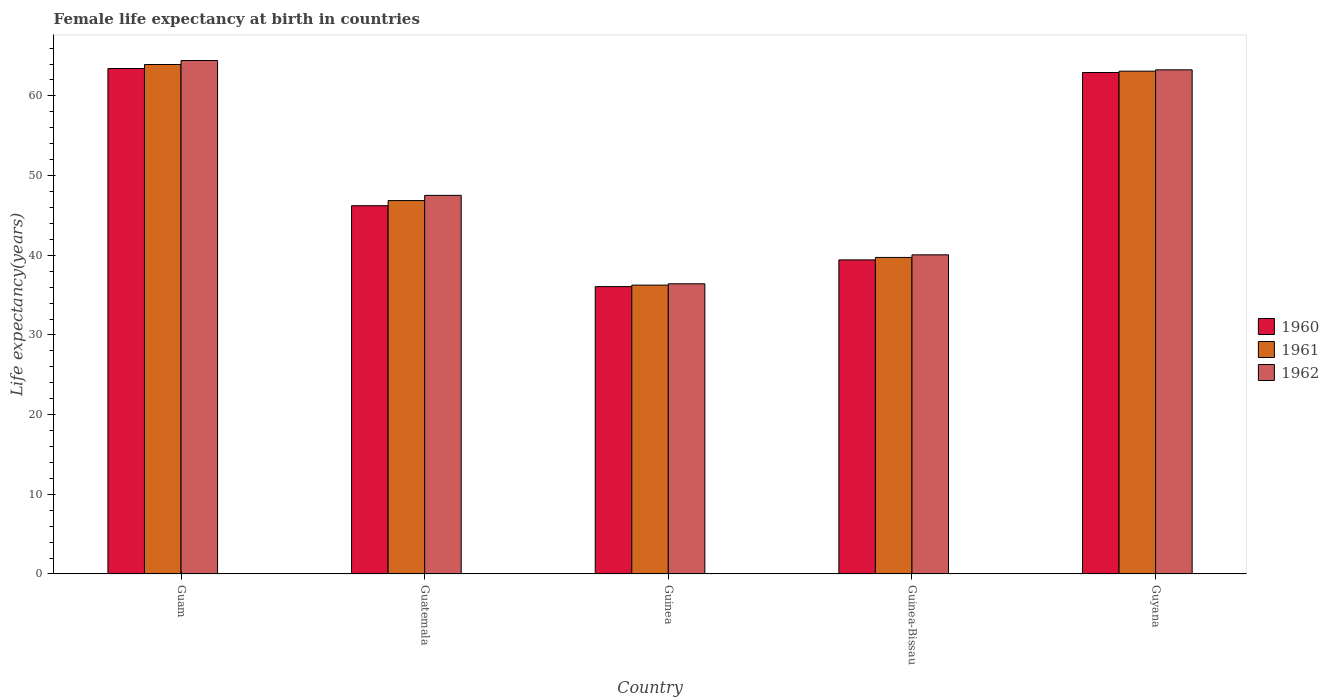How many different coloured bars are there?
Give a very brief answer. 3. Are the number of bars on each tick of the X-axis equal?
Offer a terse response. Yes. What is the label of the 1st group of bars from the left?
Offer a terse response. Guam. In how many cases, is the number of bars for a given country not equal to the number of legend labels?
Your response must be concise. 0. What is the female life expectancy at birth in 1961 in Guinea-Bissau?
Your answer should be compact. 39.73. Across all countries, what is the maximum female life expectancy at birth in 1960?
Provide a succinct answer. 63.44. Across all countries, what is the minimum female life expectancy at birth in 1962?
Offer a terse response. 36.42. In which country was the female life expectancy at birth in 1961 maximum?
Provide a succinct answer. Guam. In which country was the female life expectancy at birth in 1962 minimum?
Give a very brief answer. Guinea. What is the total female life expectancy at birth in 1962 in the graph?
Your response must be concise. 251.7. What is the difference between the female life expectancy at birth in 1961 in Guam and that in Guyana?
Give a very brief answer. 0.83. What is the difference between the female life expectancy at birth in 1960 in Guinea-Bissau and the female life expectancy at birth in 1961 in Guatemala?
Offer a very short reply. -7.44. What is the average female life expectancy at birth in 1960 per country?
Give a very brief answer. 49.62. What is the difference between the female life expectancy at birth of/in 1960 and female life expectancy at birth of/in 1962 in Guatemala?
Your answer should be compact. -1.3. In how many countries, is the female life expectancy at birth in 1962 greater than 60 years?
Provide a short and direct response. 2. What is the ratio of the female life expectancy at birth in 1961 in Guinea-Bissau to that in Guyana?
Ensure brevity in your answer.  0.63. What is the difference between the highest and the second highest female life expectancy at birth in 1962?
Your answer should be compact. 16.92. What is the difference between the highest and the lowest female life expectancy at birth in 1960?
Offer a very short reply. 27.37. In how many countries, is the female life expectancy at birth in 1961 greater than the average female life expectancy at birth in 1961 taken over all countries?
Offer a terse response. 2. What does the 1st bar from the left in Guam represents?
Your answer should be compact. 1960. What does the 3rd bar from the right in Guinea represents?
Offer a very short reply. 1960. Is it the case that in every country, the sum of the female life expectancy at birth in 1962 and female life expectancy at birth in 1960 is greater than the female life expectancy at birth in 1961?
Provide a short and direct response. Yes. How many bars are there?
Your response must be concise. 15. Does the graph contain grids?
Provide a succinct answer. No. Where does the legend appear in the graph?
Your answer should be compact. Center right. What is the title of the graph?
Offer a very short reply. Female life expectancy at birth in countries. What is the label or title of the Y-axis?
Provide a succinct answer. Life expectancy(years). What is the Life expectancy(years) in 1960 in Guam?
Ensure brevity in your answer.  63.44. What is the Life expectancy(years) in 1961 in Guam?
Make the answer very short. 63.94. What is the Life expectancy(years) in 1962 in Guam?
Offer a terse response. 64.44. What is the Life expectancy(years) of 1960 in Guatemala?
Make the answer very short. 46.22. What is the Life expectancy(years) of 1961 in Guatemala?
Ensure brevity in your answer.  46.86. What is the Life expectancy(years) in 1962 in Guatemala?
Offer a terse response. 47.52. What is the Life expectancy(years) of 1960 in Guinea?
Your answer should be compact. 36.07. What is the Life expectancy(years) of 1961 in Guinea?
Provide a short and direct response. 36.25. What is the Life expectancy(years) in 1962 in Guinea?
Offer a terse response. 36.42. What is the Life expectancy(years) in 1960 in Guinea-Bissau?
Your response must be concise. 39.42. What is the Life expectancy(years) of 1961 in Guinea-Bissau?
Keep it short and to the point. 39.73. What is the Life expectancy(years) in 1962 in Guinea-Bissau?
Offer a terse response. 40.05. What is the Life expectancy(years) in 1960 in Guyana?
Keep it short and to the point. 62.94. What is the Life expectancy(years) of 1961 in Guyana?
Your answer should be compact. 63.1. What is the Life expectancy(years) in 1962 in Guyana?
Provide a short and direct response. 63.27. Across all countries, what is the maximum Life expectancy(years) of 1960?
Offer a terse response. 63.44. Across all countries, what is the maximum Life expectancy(years) of 1961?
Offer a very short reply. 63.94. Across all countries, what is the maximum Life expectancy(years) in 1962?
Ensure brevity in your answer.  64.44. Across all countries, what is the minimum Life expectancy(years) of 1960?
Your answer should be very brief. 36.07. Across all countries, what is the minimum Life expectancy(years) of 1961?
Offer a terse response. 36.25. Across all countries, what is the minimum Life expectancy(years) in 1962?
Ensure brevity in your answer.  36.42. What is the total Life expectancy(years) in 1960 in the graph?
Ensure brevity in your answer.  248.08. What is the total Life expectancy(years) in 1961 in the graph?
Ensure brevity in your answer.  249.88. What is the total Life expectancy(years) in 1962 in the graph?
Offer a very short reply. 251.7. What is the difference between the Life expectancy(years) in 1960 in Guam and that in Guatemala?
Your answer should be compact. 17.22. What is the difference between the Life expectancy(years) in 1961 in Guam and that in Guatemala?
Keep it short and to the point. 17.08. What is the difference between the Life expectancy(years) of 1962 in Guam and that in Guatemala?
Make the answer very short. 16.92. What is the difference between the Life expectancy(years) in 1960 in Guam and that in Guinea?
Offer a very short reply. 27.37. What is the difference between the Life expectancy(years) of 1961 in Guam and that in Guinea?
Make the answer very short. 27.69. What is the difference between the Life expectancy(years) in 1962 in Guam and that in Guinea?
Keep it short and to the point. 28.02. What is the difference between the Life expectancy(years) in 1960 in Guam and that in Guinea-Bissau?
Your answer should be very brief. 24.02. What is the difference between the Life expectancy(years) in 1961 in Guam and that in Guinea-Bissau?
Give a very brief answer. 24.21. What is the difference between the Life expectancy(years) of 1962 in Guam and that in Guinea-Bissau?
Your answer should be very brief. 24.38. What is the difference between the Life expectancy(years) in 1960 in Guam and that in Guyana?
Offer a terse response. 0.5. What is the difference between the Life expectancy(years) in 1961 in Guam and that in Guyana?
Your answer should be compact. 0.83. What is the difference between the Life expectancy(years) in 1962 in Guam and that in Guyana?
Your answer should be very brief. 1.17. What is the difference between the Life expectancy(years) of 1960 in Guatemala and that in Guinea?
Your answer should be compact. 10.15. What is the difference between the Life expectancy(years) of 1961 in Guatemala and that in Guinea?
Your answer should be very brief. 10.61. What is the difference between the Life expectancy(years) in 1962 in Guatemala and that in Guinea?
Make the answer very short. 11.1. What is the difference between the Life expectancy(years) in 1960 in Guatemala and that in Guinea-Bissau?
Provide a succinct answer. 6.8. What is the difference between the Life expectancy(years) in 1961 in Guatemala and that in Guinea-Bissau?
Keep it short and to the point. 7.13. What is the difference between the Life expectancy(years) in 1962 in Guatemala and that in Guinea-Bissau?
Provide a short and direct response. 7.46. What is the difference between the Life expectancy(years) of 1960 in Guatemala and that in Guyana?
Offer a terse response. -16.72. What is the difference between the Life expectancy(years) in 1961 in Guatemala and that in Guyana?
Provide a short and direct response. -16.24. What is the difference between the Life expectancy(years) in 1962 in Guatemala and that in Guyana?
Ensure brevity in your answer.  -15.76. What is the difference between the Life expectancy(years) in 1960 in Guinea and that in Guinea-Bissau?
Make the answer very short. -3.35. What is the difference between the Life expectancy(years) in 1961 in Guinea and that in Guinea-Bissau?
Your answer should be compact. -3.48. What is the difference between the Life expectancy(years) of 1962 in Guinea and that in Guinea-Bissau?
Ensure brevity in your answer.  -3.63. What is the difference between the Life expectancy(years) of 1960 in Guinea and that in Guyana?
Provide a short and direct response. -26.87. What is the difference between the Life expectancy(years) of 1961 in Guinea and that in Guyana?
Ensure brevity in your answer.  -26.85. What is the difference between the Life expectancy(years) of 1962 in Guinea and that in Guyana?
Provide a succinct answer. -26.85. What is the difference between the Life expectancy(years) of 1960 in Guinea-Bissau and that in Guyana?
Your answer should be very brief. -23.52. What is the difference between the Life expectancy(years) in 1961 in Guinea-Bissau and that in Guyana?
Your response must be concise. -23.38. What is the difference between the Life expectancy(years) of 1962 in Guinea-Bissau and that in Guyana?
Your response must be concise. -23.22. What is the difference between the Life expectancy(years) of 1960 in Guam and the Life expectancy(years) of 1961 in Guatemala?
Ensure brevity in your answer.  16.58. What is the difference between the Life expectancy(years) of 1960 in Guam and the Life expectancy(years) of 1962 in Guatemala?
Offer a very short reply. 15.92. What is the difference between the Life expectancy(years) in 1961 in Guam and the Life expectancy(years) in 1962 in Guatemala?
Offer a terse response. 16.42. What is the difference between the Life expectancy(years) of 1960 in Guam and the Life expectancy(years) of 1961 in Guinea?
Offer a terse response. 27.19. What is the difference between the Life expectancy(years) in 1960 in Guam and the Life expectancy(years) in 1962 in Guinea?
Make the answer very short. 27.02. What is the difference between the Life expectancy(years) of 1961 in Guam and the Life expectancy(years) of 1962 in Guinea?
Your answer should be compact. 27.52. What is the difference between the Life expectancy(years) of 1960 in Guam and the Life expectancy(years) of 1961 in Guinea-Bissau?
Give a very brief answer. 23.71. What is the difference between the Life expectancy(years) of 1960 in Guam and the Life expectancy(years) of 1962 in Guinea-Bissau?
Offer a terse response. 23.38. What is the difference between the Life expectancy(years) in 1961 in Guam and the Life expectancy(years) in 1962 in Guinea-Bissau?
Make the answer very short. 23.89. What is the difference between the Life expectancy(years) of 1960 in Guam and the Life expectancy(years) of 1961 in Guyana?
Your answer should be compact. 0.33. What is the difference between the Life expectancy(years) of 1960 in Guam and the Life expectancy(years) of 1962 in Guyana?
Make the answer very short. 0.17. What is the difference between the Life expectancy(years) in 1961 in Guam and the Life expectancy(years) in 1962 in Guyana?
Keep it short and to the point. 0.67. What is the difference between the Life expectancy(years) of 1960 in Guatemala and the Life expectancy(years) of 1961 in Guinea?
Your answer should be compact. 9.97. What is the difference between the Life expectancy(years) in 1960 in Guatemala and the Life expectancy(years) in 1962 in Guinea?
Your response must be concise. 9.8. What is the difference between the Life expectancy(years) of 1961 in Guatemala and the Life expectancy(years) of 1962 in Guinea?
Keep it short and to the point. 10.44. What is the difference between the Life expectancy(years) in 1960 in Guatemala and the Life expectancy(years) in 1961 in Guinea-Bissau?
Keep it short and to the point. 6.49. What is the difference between the Life expectancy(years) in 1960 in Guatemala and the Life expectancy(years) in 1962 in Guinea-Bissau?
Your answer should be very brief. 6.17. What is the difference between the Life expectancy(years) in 1961 in Guatemala and the Life expectancy(years) in 1962 in Guinea-Bissau?
Make the answer very short. 6.81. What is the difference between the Life expectancy(years) of 1960 in Guatemala and the Life expectancy(years) of 1961 in Guyana?
Provide a short and direct response. -16.89. What is the difference between the Life expectancy(years) of 1960 in Guatemala and the Life expectancy(years) of 1962 in Guyana?
Keep it short and to the point. -17.05. What is the difference between the Life expectancy(years) of 1961 in Guatemala and the Life expectancy(years) of 1962 in Guyana?
Your response must be concise. -16.41. What is the difference between the Life expectancy(years) of 1960 in Guinea and the Life expectancy(years) of 1961 in Guinea-Bissau?
Ensure brevity in your answer.  -3.66. What is the difference between the Life expectancy(years) of 1960 in Guinea and the Life expectancy(years) of 1962 in Guinea-Bissau?
Give a very brief answer. -3.99. What is the difference between the Life expectancy(years) in 1961 in Guinea and the Life expectancy(years) in 1962 in Guinea-Bissau?
Provide a short and direct response. -3.8. What is the difference between the Life expectancy(years) of 1960 in Guinea and the Life expectancy(years) of 1961 in Guyana?
Offer a very short reply. -27.04. What is the difference between the Life expectancy(years) in 1960 in Guinea and the Life expectancy(years) in 1962 in Guyana?
Your answer should be very brief. -27.2. What is the difference between the Life expectancy(years) in 1961 in Guinea and the Life expectancy(years) in 1962 in Guyana?
Make the answer very short. -27.02. What is the difference between the Life expectancy(years) in 1960 in Guinea-Bissau and the Life expectancy(years) in 1961 in Guyana?
Keep it short and to the point. -23.69. What is the difference between the Life expectancy(years) of 1960 in Guinea-Bissau and the Life expectancy(years) of 1962 in Guyana?
Offer a very short reply. -23.85. What is the difference between the Life expectancy(years) in 1961 in Guinea-Bissau and the Life expectancy(years) in 1962 in Guyana?
Give a very brief answer. -23.55. What is the average Life expectancy(years) of 1960 per country?
Provide a short and direct response. 49.62. What is the average Life expectancy(years) in 1961 per country?
Your answer should be compact. 49.98. What is the average Life expectancy(years) of 1962 per country?
Your answer should be compact. 50.34. What is the difference between the Life expectancy(years) in 1960 and Life expectancy(years) in 1961 in Guam?
Offer a very short reply. -0.5. What is the difference between the Life expectancy(years) of 1960 and Life expectancy(years) of 1962 in Guam?
Give a very brief answer. -1. What is the difference between the Life expectancy(years) of 1961 and Life expectancy(years) of 1962 in Guam?
Ensure brevity in your answer.  -0.5. What is the difference between the Life expectancy(years) in 1960 and Life expectancy(years) in 1961 in Guatemala?
Your answer should be compact. -0.64. What is the difference between the Life expectancy(years) in 1960 and Life expectancy(years) in 1962 in Guatemala?
Give a very brief answer. -1.3. What is the difference between the Life expectancy(years) in 1961 and Life expectancy(years) in 1962 in Guatemala?
Offer a very short reply. -0.65. What is the difference between the Life expectancy(years) of 1960 and Life expectancy(years) of 1961 in Guinea?
Your response must be concise. -0.18. What is the difference between the Life expectancy(years) of 1960 and Life expectancy(years) of 1962 in Guinea?
Your response must be concise. -0.35. What is the difference between the Life expectancy(years) in 1961 and Life expectancy(years) in 1962 in Guinea?
Provide a succinct answer. -0.17. What is the difference between the Life expectancy(years) of 1960 and Life expectancy(years) of 1961 in Guinea-Bissau?
Offer a terse response. -0.31. What is the difference between the Life expectancy(years) in 1960 and Life expectancy(years) in 1962 in Guinea-Bissau?
Offer a very short reply. -0.64. What is the difference between the Life expectancy(years) of 1961 and Life expectancy(years) of 1962 in Guinea-Bissau?
Keep it short and to the point. -0.33. What is the difference between the Life expectancy(years) of 1960 and Life expectancy(years) of 1961 in Guyana?
Offer a very short reply. -0.17. What is the difference between the Life expectancy(years) in 1960 and Life expectancy(years) in 1962 in Guyana?
Give a very brief answer. -0.34. What is the difference between the Life expectancy(years) of 1961 and Life expectancy(years) of 1962 in Guyana?
Your response must be concise. -0.17. What is the ratio of the Life expectancy(years) of 1960 in Guam to that in Guatemala?
Provide a succinct answer. 1.37. What is the ratio of the Life expectancy(years) of 1961 in Guam to that in Guatemala?
Ensure brevity in your answer.  1.36. What is the ratio of the Life expectancy(years) of 1962 in Guam to that in Guatemala?
Give a very brief answer. 1.36. What is the ratio of the Life expectancy(years) of 1960 in Guam to that in Guinea?
Your answer should be compact. 1.76. What is the ratio of the Life expectancy(years) in 1961 in Guam to that in Guinea?
Keep it short and to the point. 1.76. What is the ratio of the Life expectancy(years) in 1962 in Guam to that in Guinea?
Your answer should be very brief. 1.77. What is the ratio of the Life expectancy(years) of 1960 in Guam to that in Guinea-Bissau?
Offer a terse response. 1.61. What is the ratio of the Life expectancy(years) of 1961 in Guam to that in Guinea-Bissau?
Your response must be concise. 1.61. What is the ratio of the Life expectancy(years) in 1962 in Guam to that in Guinea-Bissau?
Keep it short and to the point. 1.61. What is the ratio of the Life expectancy(years) of 1960 in Guam to that in Guyana?
Keep it short and to the point. 1.01. What is the ratio of the Life expectancy(years) of 1961 in Guam to that in Guyana?
Your answer should be very brief. 1.01. What is the ratio of the Life expectancy(years) in 1962 in Guam to that in Guyana?
Provide a short and direct response. 1.02. What is the ratio of the Life expectancy(years) of 1960 in Guatemala to that in Guinea?
Provide a succinct answer. 1.28. What is the ratio of the Life expectancy(years) in 1961 in Guatemala to that in Guinea?
Give a very brief answer. 1.29. What is the ratio of the Life expectancy(years) in 1962 in Guatemala to that in Guinea?
Your answer should be compact. 1.3. What is the ratio of the Life expectancy(years) of 1960 in Guatemala to that in Guinea-Bissau?
Provide a succinct answer. 1.17. What is the ratio of the Life expectancy(years) in 1961 in Guatemala to that in Guinea-Bissau?
Offer a very short reply. 1.18. What is the ratio of the Life expectancy(years) in 1962 in Guatemala to that in Guinea-Bissau?
Your answer should be compact. 1.19. What is the ratio of the Life expectancy(years) in 1960 in Guatemala to that in Guyana?
Your response must be concise. 0.73. What is the ratio of the Life expectancy(years) of 1961 in Guatemala to that in Guyana?
Your answer should be compact. 0.74. What is the ratio of the Life expectancy(years) of 1962 in Guatemala to that in Guyana?
Your answer should be very brief. 0.75. What is the ratio of the Life expectancy(years) in 1960 in Guinea to that in Guinea-Bissau?
Make the answer very short. 0.92. What is the ratio of the Life expectancy(years) in 1961 in Guinea to that in Guinea-Bissau?
Keep it short and to the point. 0.91. What is the ratio of the Life expectancy(years) in 1962 in Guinea to that in Guinea-Bissau?
Your response must be concise. 0.91. What is the ratio of the Life expectancy(years) of 1960 in Guinea to that in Guyana?
Your answer should be compact. 0.57. What is the ratio of the Life expectancy(years) in 1961 in Guinea to that in Guyana?
Make the answer very short. 0.57. What is the ratio of the Life expectancy(years) of 1962 in Guinea to that in Guyana?
Ensure brevity in your answer.  0.58. What is the ratio of the Life expectancy(years) of 1960 in Guinea-Bissau to that in Guyana?
Your response must be concise. 0.63. What is the ratio of the Life expectancy(years) in 1961 in Guinea-Bissau to that in Guyana?
Your response must be concise. 0.63. What is the ratio of the Life expectancy(years) of 1962 in Guinea-Bissau to that in Guyana?
Offer a very short reply. 0.63. What is the difference between the highest and the second highest Life expectancy(years) in 1960?
Your answer should be compact. 0.5. What is the difference between the highest and the second highest Life expectancy(years) in 1961?
Your response must be concise. 0.83. What is the difference between the highest and the second highest Life expectancy(years) of 1962?
Offer a terse response. 1.17. What is the difference between the highest and the lowest Life expectancy(years) in 1960?
Offer a terse response. 27.37. What is the difference between the highest and the lowest Life expectancy(years) in 1961?
Offer a very short reply. 27.69. What is the difference between the highest and the lowest Life expectancy(years) in 1962?
Your answer should be very brief. 28.02. 